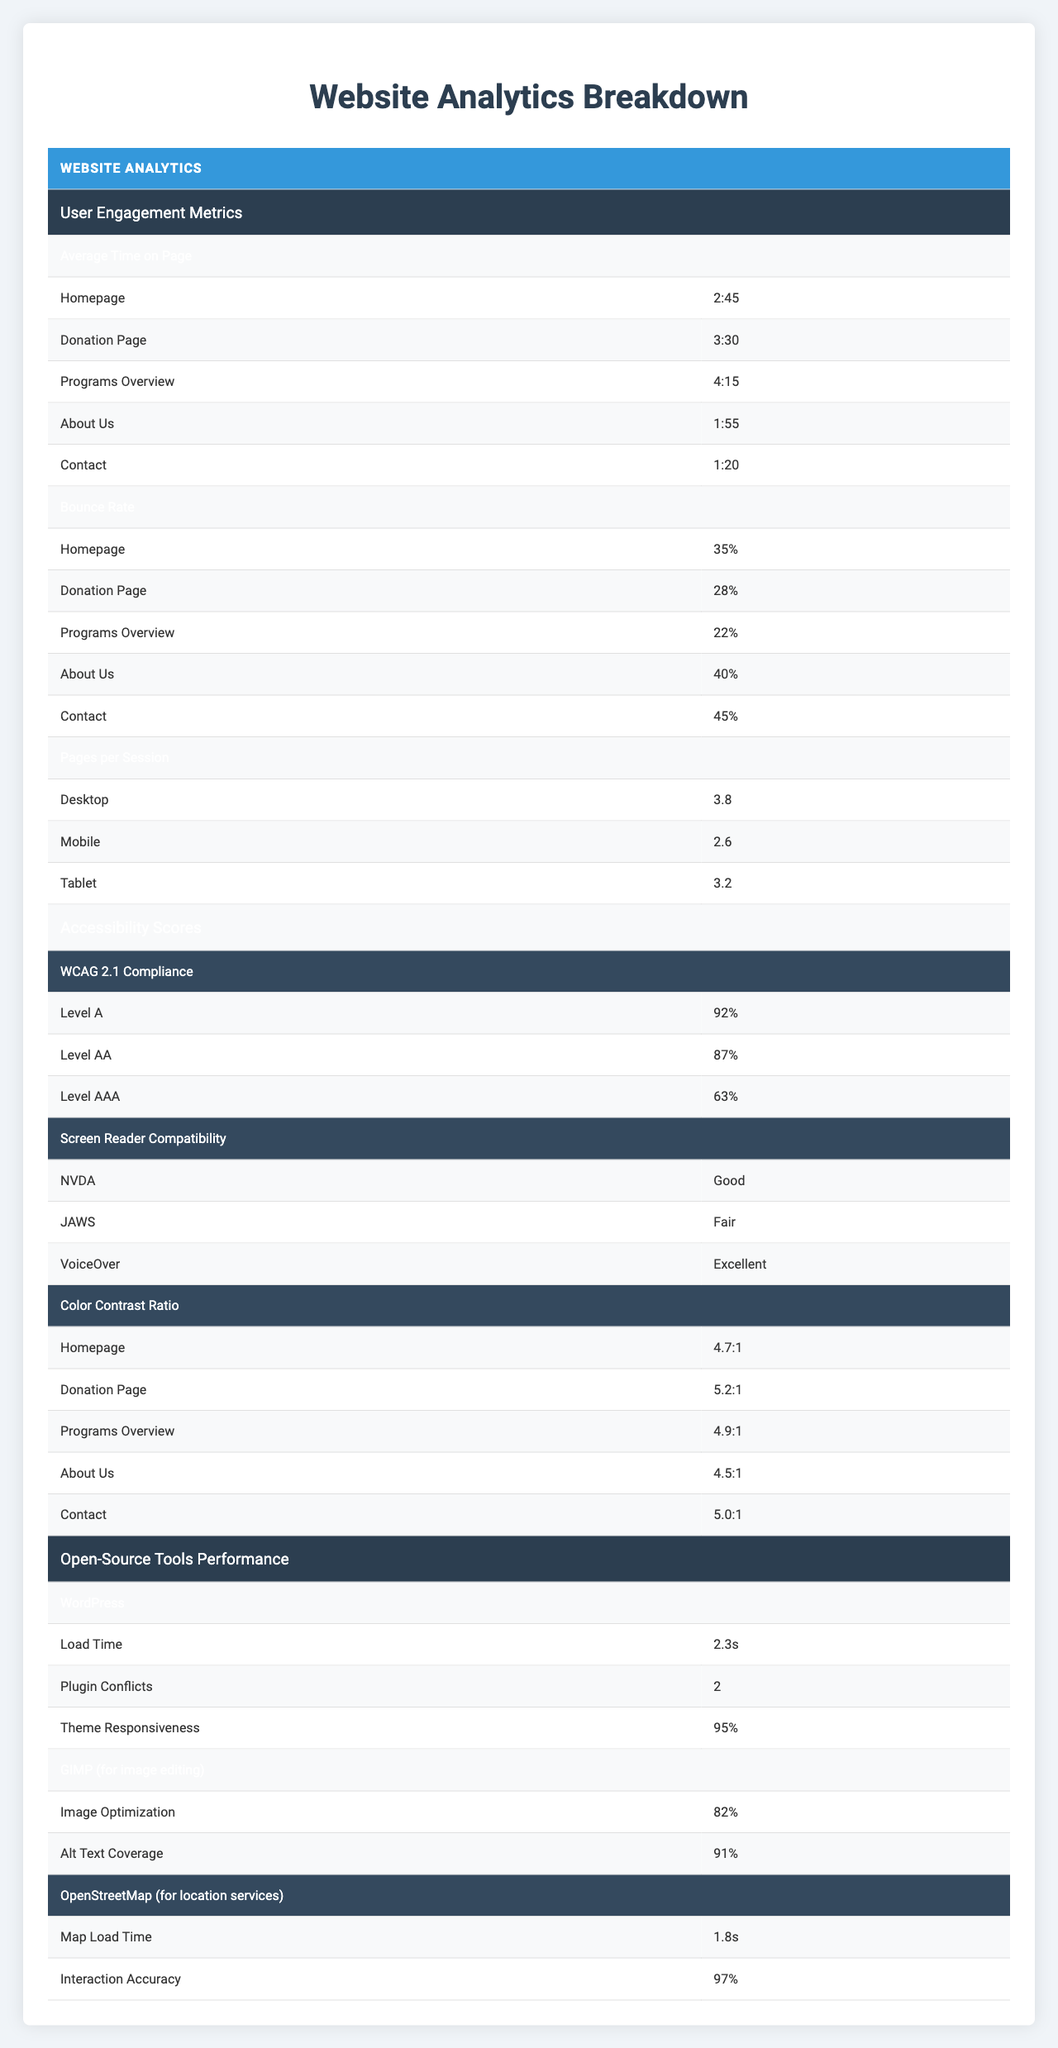What is the average time on the Donation Page? The table shows "Average Time on Page," and for the Donation Page, the specified time is "3:30," which represents 3 minutes and 30 seconds.
Answer: 3:30 What is the bounce rate for the About Us page? Referring to the "Bounce Rate" section, the bounce rate for the About Us page is listed as "40%."
Answer: 40% Which device type has the highest pages per session? In the "Pages per Session" section, Desktop is listed with 3.8, Mobile with 2.6, and Tablet with 3.2. Here, Desktop has the highest value.
Answer: Desktop Is the screen reader compatibility for NVDA good? According to the "Screen Reader Compatibility" section, NVDA is labeled as "Good."
Answer: Yes Which page has the longest average time spent by users? The "Average Time on Page" shows "Programs Overview" with 4:15, while others are shorter. Therefore, Programs Overview has the longest average time.
Answer: Programs Overview What is the average bounce rate across all pages? The bounce rates are: 35% (Homepage), 28% (Donation Page), 22% (Programs Overview), 40% (About Us), and 45% (Contact). Calculating the sum: 35 + 28 + 22 + 40 + 45 = 170. There are 5 pages, so the average is 170 / 5 = 34%.
Answer: 34% Which page has the best color contrast ratio? The color contrast ratios are: Homepage (4.7:1), Donation Page (5.2:1), Programs Overview (4.9:1), About Us (4.5:1), and Contact (5.0:1). The highest value is for the Donation Page at 5.2:1.
Answer: Donation Page What percentage of WCAG Level AA compliance does the site achieve? The "WCAG 2.1 Compliance" section shows that Level AA compliance is achieved at "87%."
Answer: 87% Is the interaction accuracy of OpenStreetMap above 95%? The table specifies that OpenStreetMap has an "Interaction Accuracy" of "97%," which is above 95%.
Answer: Yes If users spend an average of 2 minutes more on the Donation Page than on the Home page, what is the average time spent on the Homepage? The time spent on the Donation Page is 3:30. If it's 2 minutes more than the Homepage, then we need to subtract 2 minutes from 3:30. 3:30 minus 2:00 gives 1:30.
Answer: 1:30 